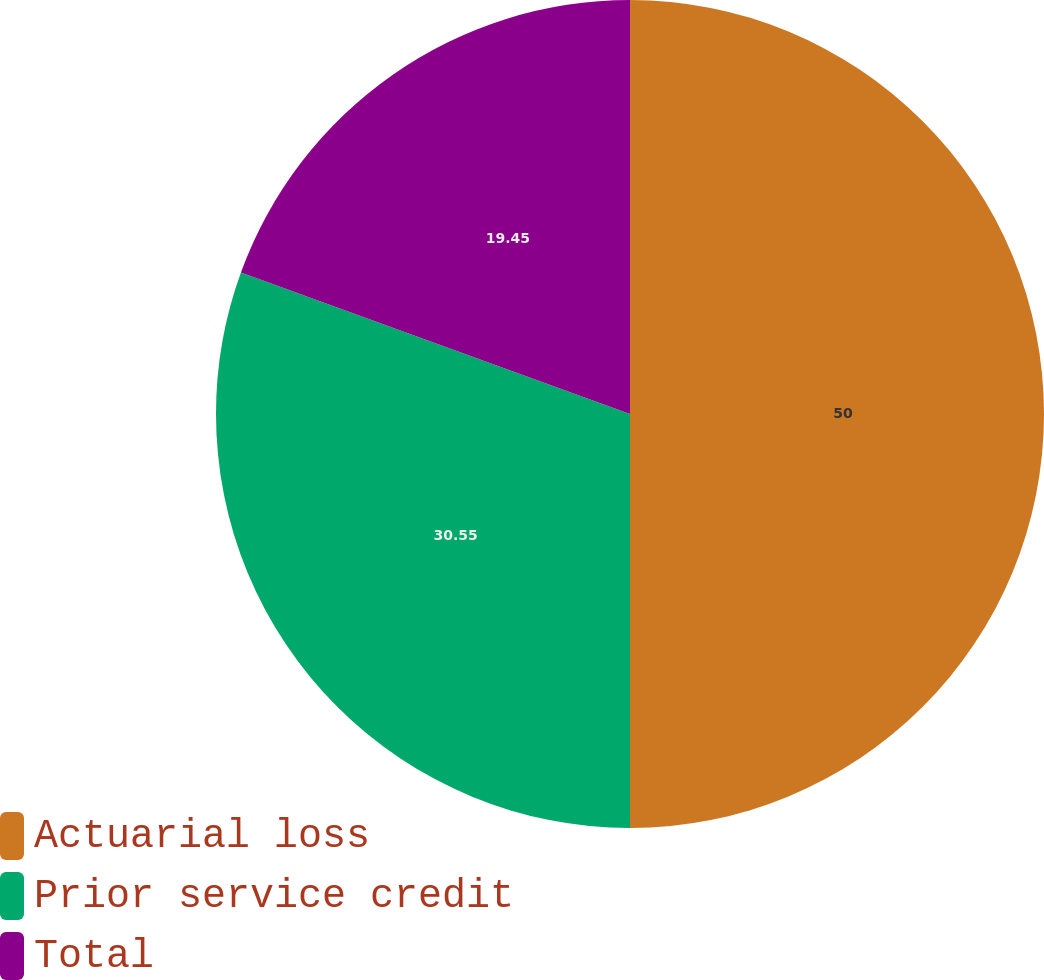Convert chart. <chart><loc_0><loc_0><loc_500><loc_500><pie_chart><fcel>Actuarial loss<fcel>Prior service credit<fcel>Total<nl><fcel>50.0%<fcel>30.55%<fcel>19.45%<nl></chart> 